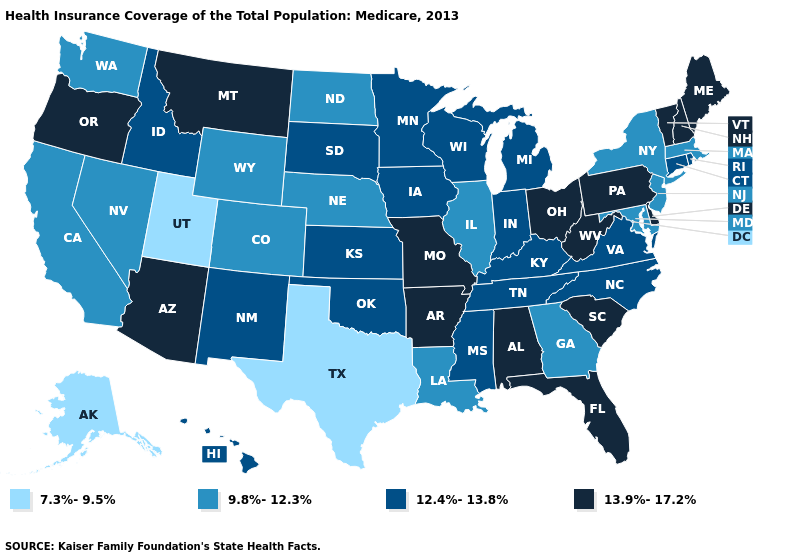Name the states that have a value in the range 7.3%-9.5%?
Quick response, please. Alaska, Texas, Utah. What is the value of Ohio?
Answer briefly. 13.9%-17.2%. What is the value of Washington?
Keep it brief. 9.8%-12.3%. Which states have the highest value in the USA?
Concise answer only. Alabama, Arizona, Arkansas, Delaware, Florida, Maine, Missouri, Montana, New Hampshire, Ohio, Oregon, Pennsylvania, South Carolina, Vermont, West Virginia. Name the states that have a value in the range 13.9%-17.2%?
Write a very short answer. Alabama, Arizona, Arkansas, Delaware, Florida, Maine, Missouri, Montana, New Hampshire, Ohio, Oregon, Pennsylvania, South Carolina, Vermont, West Virginia. How many symbols are there in the legend?
Answer briefly. 4. What is the value of Wyoming?
Keep it brief. 9.8%-12.3%. Which states have the lowest value in the South?
Keep it brief. Texas. Does the first symbol in the legend represent the smallest category?
Concise answer only. Yes. How many symbols are there in the legend?
Be succinct. 4. Among the states that border Pennsylvania , which have the highest value?
Give a very brief answer. Delaware, Ohio, West Virginia. What is the value of Minnesota?
Short answer required. 12.4%-13.8%. Does Texas have the lowest value in the USA?
Write a very short answer. Yes. Does Maine have the highest value in the USA?
Be succinct. Yes. What is the highest value in the USA?
Keep it brief. 13.9%-17.2%. 